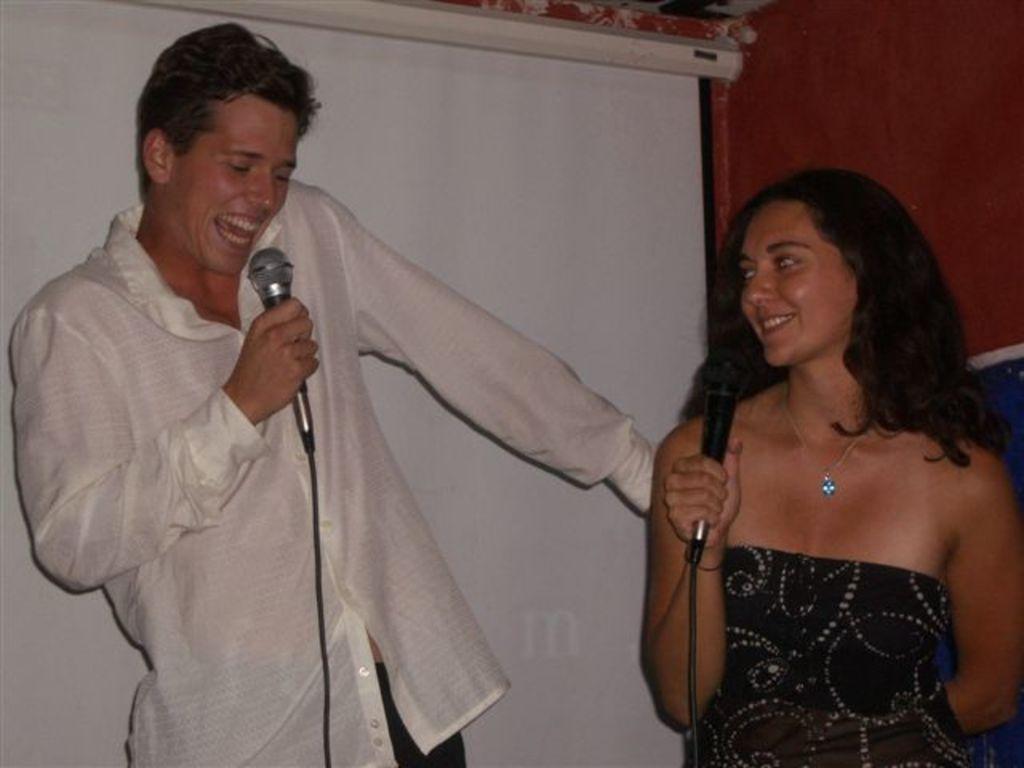Could you give a brief overview of what you see in this image? In this image i can see a man standing smiling and holding a micro phone, he is wearing a white shirt at right there is a woman standing smiling and holding a micro phone wearing a black dress at the background i can see a white screen and a brown wall. 